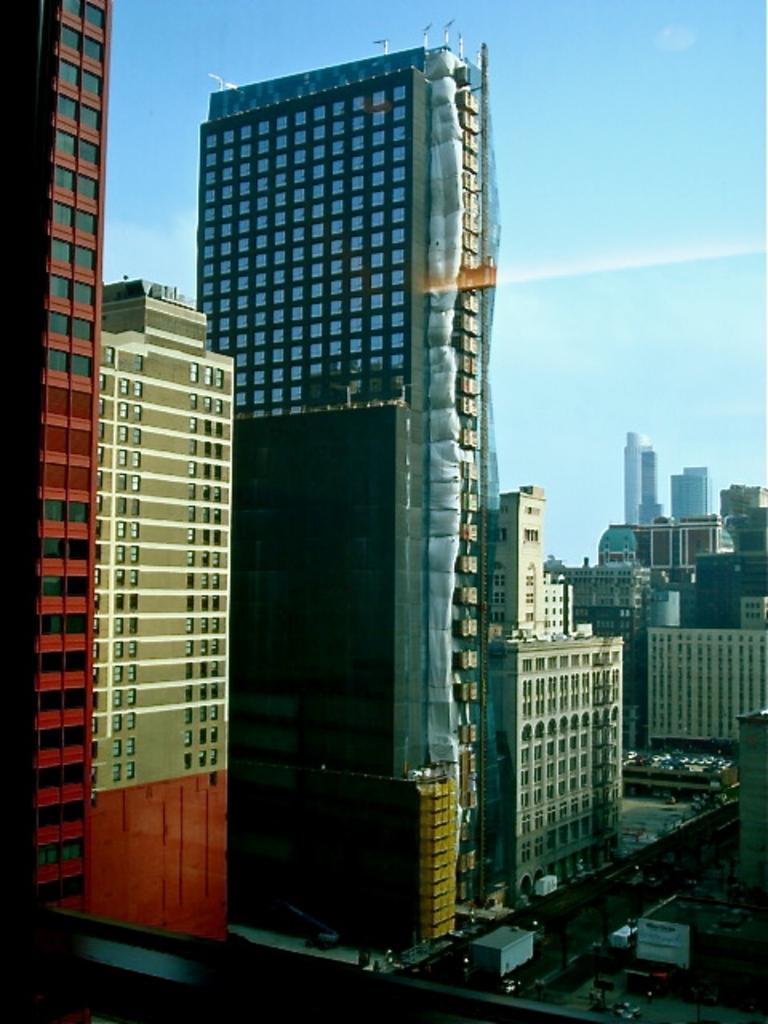Could you give a brief overview of what you see in this image? In the image there are many tall buildings and in between those buildings there is a road and there are some vehicles on the road. 